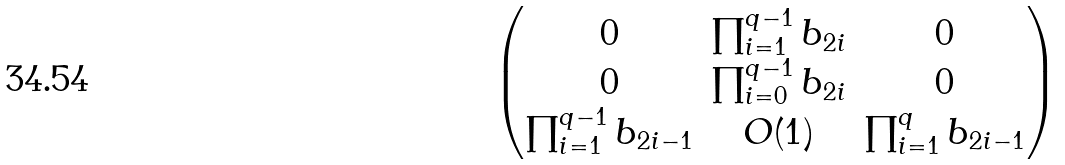<formula> <loc_0><loc_0><loc_500><loc_500>\begin{pmatrix} 0 & \prod _ { i = 1 } ^ { q - 1 } b _ { 2 i } & 0 \\ 0 & \prod _ { i = 0 } ^ { q - 1 } b _ { 2 i } & 0 \\ \prod _ { i = 1 } ^ { q - 1 } b _ { 2 i - 1 } & O ( 1 ) & \prod _ { i = 1 } ^ { q } b _ { 2 i - 1 } \end{pmatrix}</formula> 